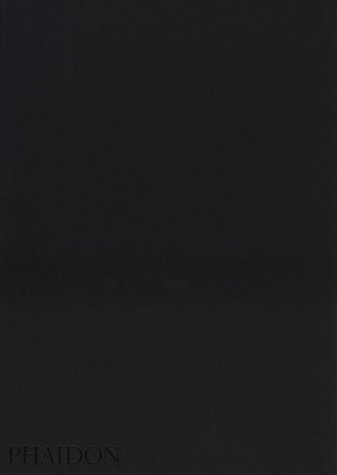Who is the author of this book?
Answer the question using a single word or phrase. Larry Towell What is the title of this book? The Mennonites What is the genre of this book? Christian Books & Bibles Is this book related to Christian Books & Bibles? Yes Is this book related to Humor & Entertainment? No 